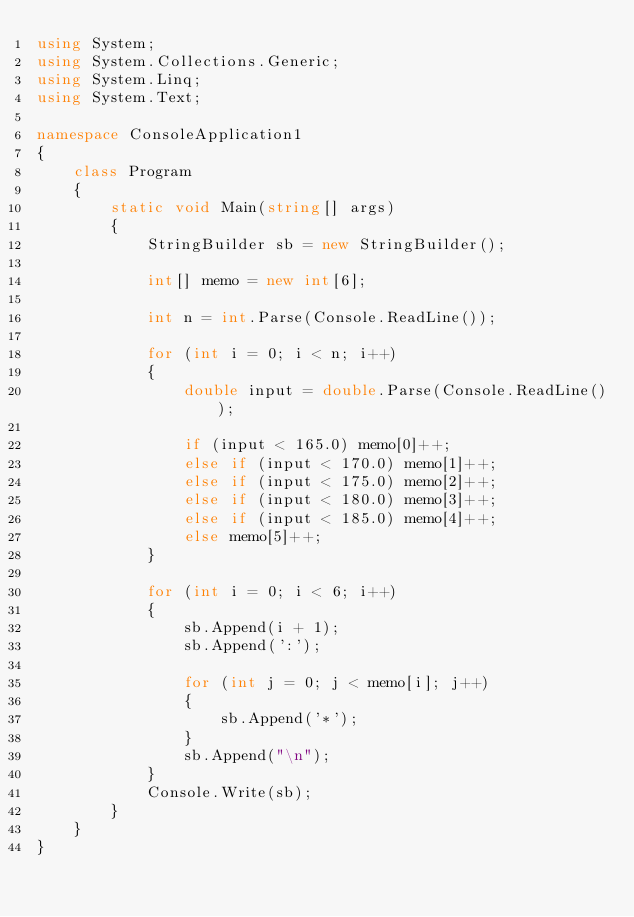<code> <loc_0><loc_0><loc_500><loc_500><_C#_>using System;
using System.Collections.Generic;
using System.Linq;
using System.Text;

namespace ConsoleApplication1
{
    class Program
    {
        static void Main(string[] args)
        {
            StringBuilder sb = new StringBuilder();

            int[] memo = new int[6];

            int n = int.Parse(Console.ReadLine());

            for (int i = 0; i < n; i++)
            {
                double input = double.Parse(Console.ReadLine());

                if (input < 165.0) memo[0]++;
                else if (input < 170.0) memo[1]++;
                else if (input < 175.0) memo[2]++;
                else if (input < 180.0) memo[3]++;
                else if (input < 185.0) memo[4]++;
                else memo[5]++;
            }

            for (int i = 0; i < 6; i++)
            {
                sb.Append(i + 1);
                sb.Append(':');

                for (int j = 0; j < memo[i]; j++)
                {
                    sb.Append('*');
                }
                sb.Append("\n");
            }
            Console.Write(sb);
        }
    }
}</code> 